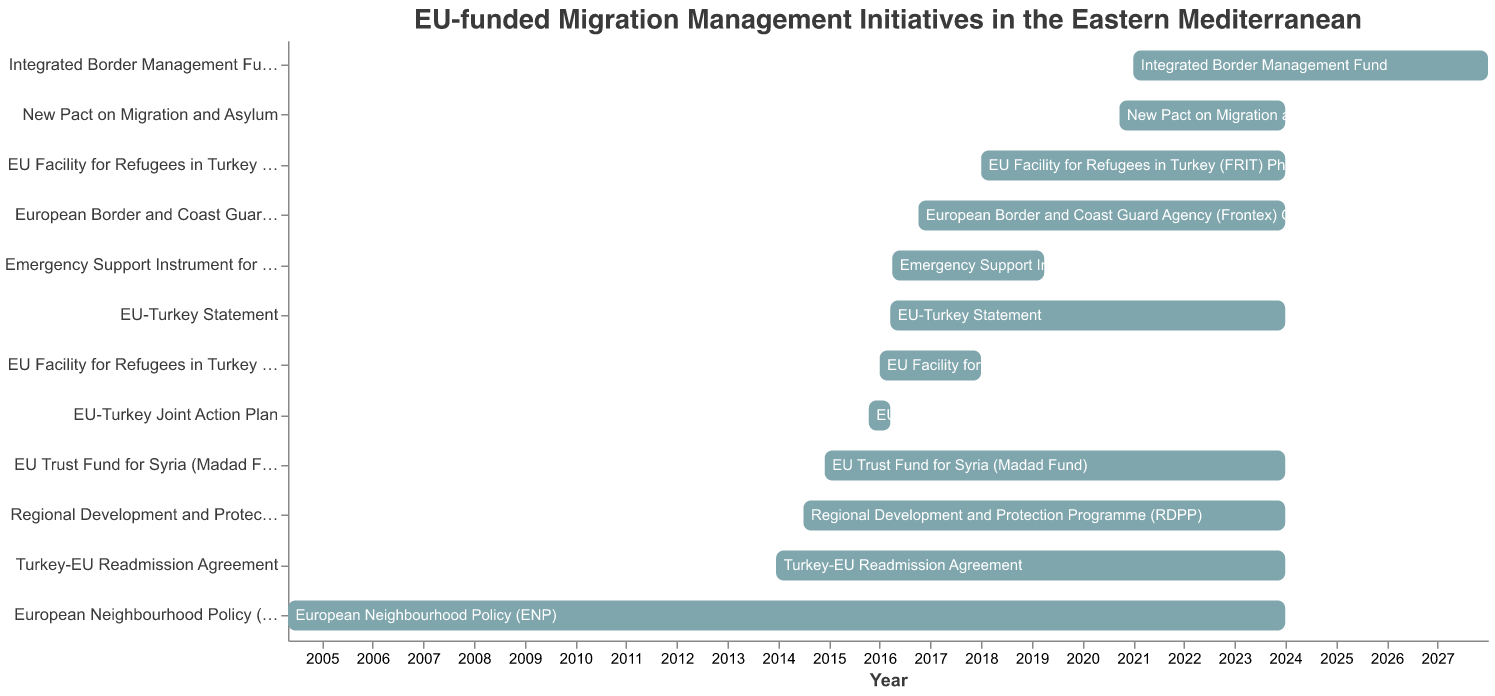What is the duration of the "EU Facility for Refugees in Turkey (FRIT) Phase I"? The start date of "EU Facility for Refugees in Turkey (FRIT) Phase I" is 2016-01-01, and the end date is 2017-12-31. To calculate the duration, we take the difference between the start and end dates. "From January 1, 2016, to December 31, 2017," makes a total duration of approximately two years.
Answer: Two years Which project starts the earliest? To find the project that starts the earliest, we look at the project's start dates in the figure. The "European Neighbourhood Policy (ENP)" starts on 2004-05-01, which is earlier compared to all other projects.
Answer: European Neighbourhood Policy (ENP) What is the time range of the "Turkey-EU Readmission Agreement"? The "Turkey-EU Readmission Agreement" starts on 2013-12-16 and ends on 2023-12-31. To find the time range, we subtract the start year from the end year, which results in around 10 years.
Answer: Approximately 10 years Which projects are ongoing in 2021? To find the projects ongoing in 2021, we check the start and end dates to see which projects include the year 2021. These projects are "European Neighbourhood Policy (ENP)", "Turkey-EU Readmission Agreement", "EU-Turkey Statement", "EU Trust Fund for Syria (Madad Fund)", "European Border and Coast Guard Agency (Frontex) Operations", "EU Facility for Refugees in Turkey (FRIT) Phase II", "Regional Development and Protection Programme (RDPP)", "Integrated Border Management Fund", and "New Pact on Migration and Asylum".
Answer: Nine projects Which project has the shortest duration? To determine the shortest project duration, we compare the durations of each project. The "EU-Turkey Joint Action Plan" has the shortest duration, starting on 2015-10-15 and ending on 2016-03-18, which is about five months.
Answer: EU-Turkey Joint Action Plan What is the difference in end dates between the "Emergency Support Instrument for Greece" and the "EU Facility for Refugees in Turkey (FRIT) Phase I"? The "Emergency Support Instrument for Greece" ended on 2019-03-31, and the "EU Facility for Refugees in Turkey (FRIT) Phase I" ended on 2017-12-31. The difference in end dates is from December 31, 2017, to March 31, 2019, which is 1 year and 3 months.
Answer: 1 year and 3 months Which project has the longest duration? To find the longest duration project, we need to check all the time ranges. The "European Neighbourhood Policy (ENP)" has the longest duration, starting from 2004-05-01 and ending on 2023-12-31, which covers around 19 years and 8 months.
Answer: European Neighbourhood Policy (ENP) When did the "New Pact on Migration and Asylum" start? To find the start date of the "New Pact on Migration and Asylum", we look at the data points in the figure. It started on 2020-09-23.
Answer: 2020-09-23 